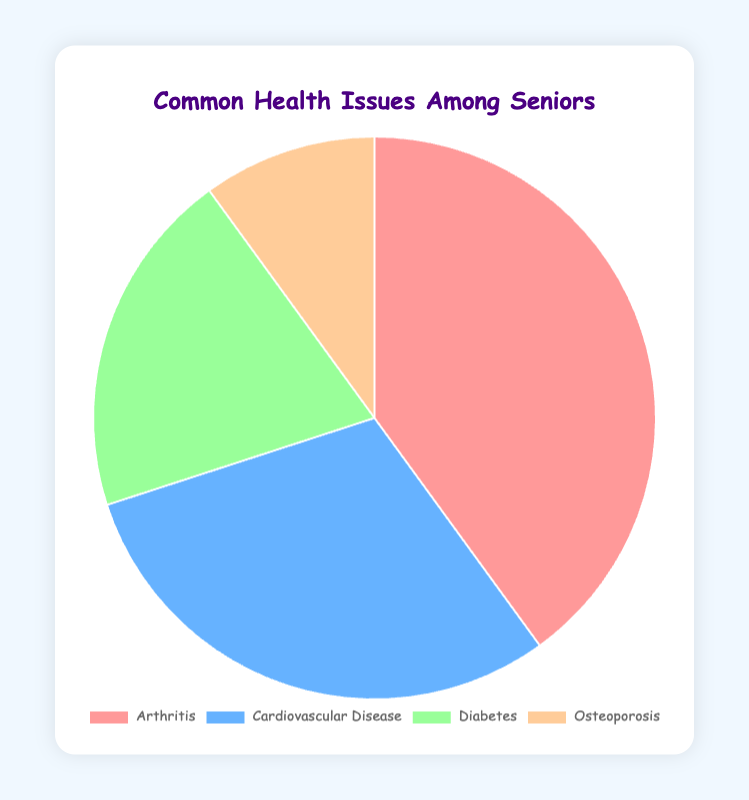What health issue has the largest proportion among seniors? The largest portion of the pie chart is for Arthritis, which takes up 40% of the total proportion.
Answer: Arthritis Which health issue has the smallest proportion among seniors? The smallest portion of the pie chart is for Osteoporosis, which takes up 10% of the total proportion.
Answer: Osteoporosis How much larger is the proportion of Arthritis compared to Cardiovascular Disease? The proportion of Arthritis is 40%, and the proportion of Cardiovascular Disease is 30%. The difference is 40% - 30% = 10%.
Answer: 10% What is the combined proportion of Diabetes and Osteoporosis? The proportion of Diabetes is 20%, and the proportion of Osteoporosis is 10%. The combined proportion is 20% + 10% = 30%.
Answer: 30% Which two health issues together equal the proportion of Arthritis? The proportion of Arthritis is 40%. The combined proportion of Cardiovascular Disease (30%) and Osteoporosis (10%) equals 30% + 10% = 40%, which is equal to the proportion of Arthritis.
Answer: Cardiovascular Disease and Osteoporosis What proportion of seniors suffer from conditions other than Arthritis? The total proportion of other health conditions (Cardiovascular Disease, Diabetes, and Osteoporosis) is 30% + 20% + 10% = 60%.
Answer: 60% By what factor is the proportion of Arthritis greater than Osteoporosis? The proportion of Arthritis is 40%, and the proportion of Osteoporosis is 10%. The factor is 40% / 10% = 4.
Answer: 4 What is the average proportion of the four health issues among seniors? The proportions are 40%, 30%, 20%, and 10%. The sum is 40% + 30% + 20% + 10% = 100%. There are 4 issues, so the average is 100% / 4 = 25%.
Answer: 25% 